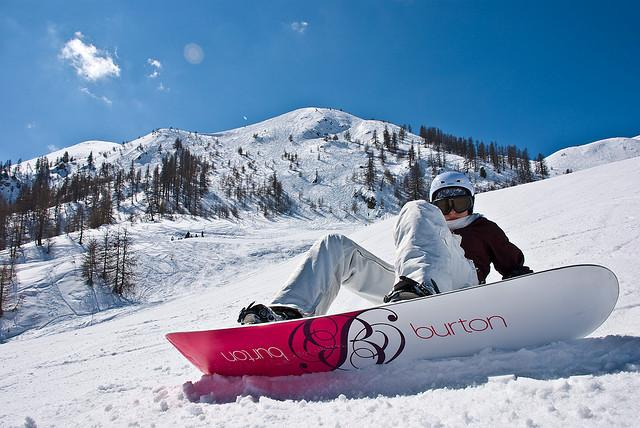Who crafted the thing on the person's feet?

Choices:
A) company
B) shoe maker
C) hobbyist
D) jeweler company 